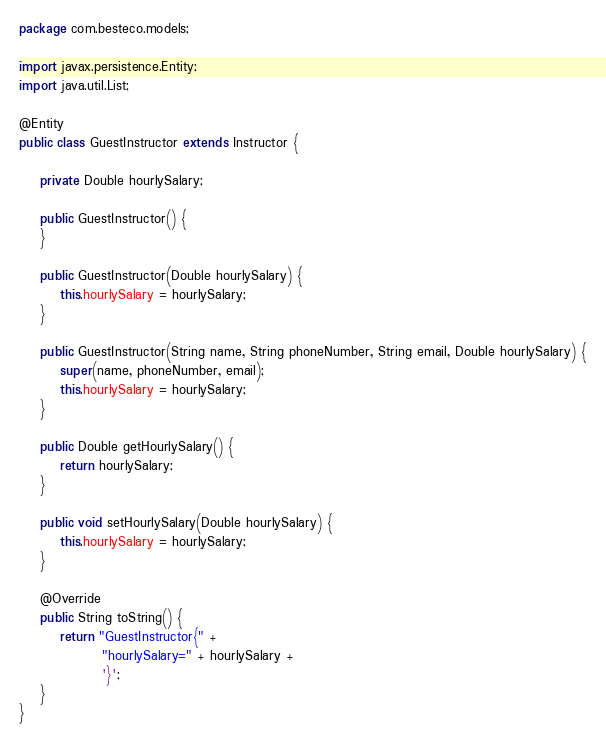Convert code to text. <code><loc_0><loc_0><loc_500><loc_500><_Java_>package com.besteco.models;

import javax.persistence.Entity;
import java.util.List;

@Entity
public class GuestInstructor extends Instructor {

    private Double hourlySalary;

    public GuestInstructor() {
    }

    public GuestInstructor(Double hourlySalary) {
        this.hourlySalary = hourlySalary;
    }

    public GuestInstructor(String name, String phoneNumber, String email, Double hourlySalary) {
        super(name, phoneNumber, email);
        this.hourlySalary = hourlySalary;
    }

    public Double getHourlySalary() {
        return hourlySalary;
    }

    public void setHourlySalary(Double hourlySalary) {
        this.hourlySalary = hourlySalary;
    }

    @Override
    public String toString() {
        return "GuestInstructor{" +
                "hourlySalary=" + hourlySalary +
                '}';
    }
}
</code> 